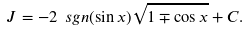Convert formula to latex. <formula><loc_0><loc_0><loc_500><loc_500>J = - 2 \ s g n ( \sin x ) \sqrt { 1 \mp \cos x } + C .</formula> 